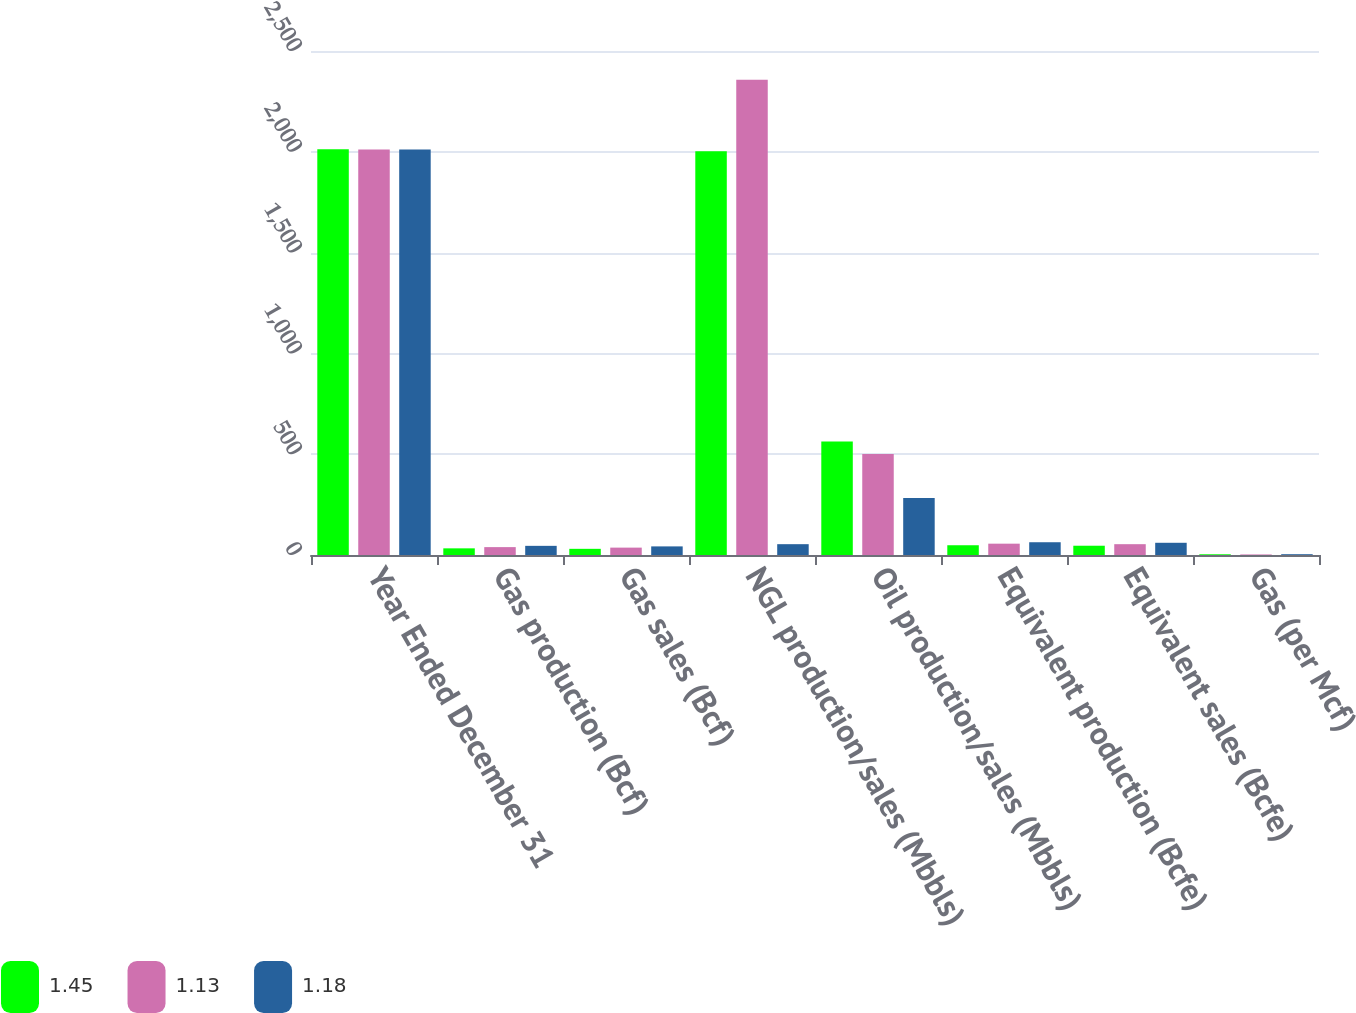Convert chart to OTSL. <chart><loc_0><loc_0><loc_500><loc_500><stacked_bar_chart><ecel><fcel>Year Ended December 31<fcel>Gas production (Bcf)<fcel>Gas sales (Bcf)<fcel>NGL production/sales (Mbbls)<fcel>Oil production/sales (Mbbls)<fcel>Equivalent production (Bcfe)<fcel>Equivalent sales (Bcfe)<fcel>Gas (per Mcf)<nl><fcel>1.45<fcel>2013<fcel>33<fcel>30.6<fcel>2002.2<fcel>563.6<fcel>48.4<fcel>46<fcel>3.53<nl><fcel>1.13<fcel>2012<fcel>39.1<fcel>36.6<fcel>2357.2<fcel>501<fcel>56.2<fcel>53.7<fcel>2.67<nl><fcel>1.18<fcel>2011<fcel>45.4<fcel>42.7<fcel>53.7<fcel>282.2<fcel>63.3<fcel>60.6<fcel>3.94<nl></chart> 